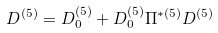Convert formula to latex. <formula><loc_0><loc_0><loc_500><loc_500>D ^ { ( 5 ) } = D _ { 0 } ^ { ( 5 ) } + D _ { 0 } ^ { ( 5 ) } \Pi ^ { * ( 5 ) } D ^ { ( 5 ) }</formula> 